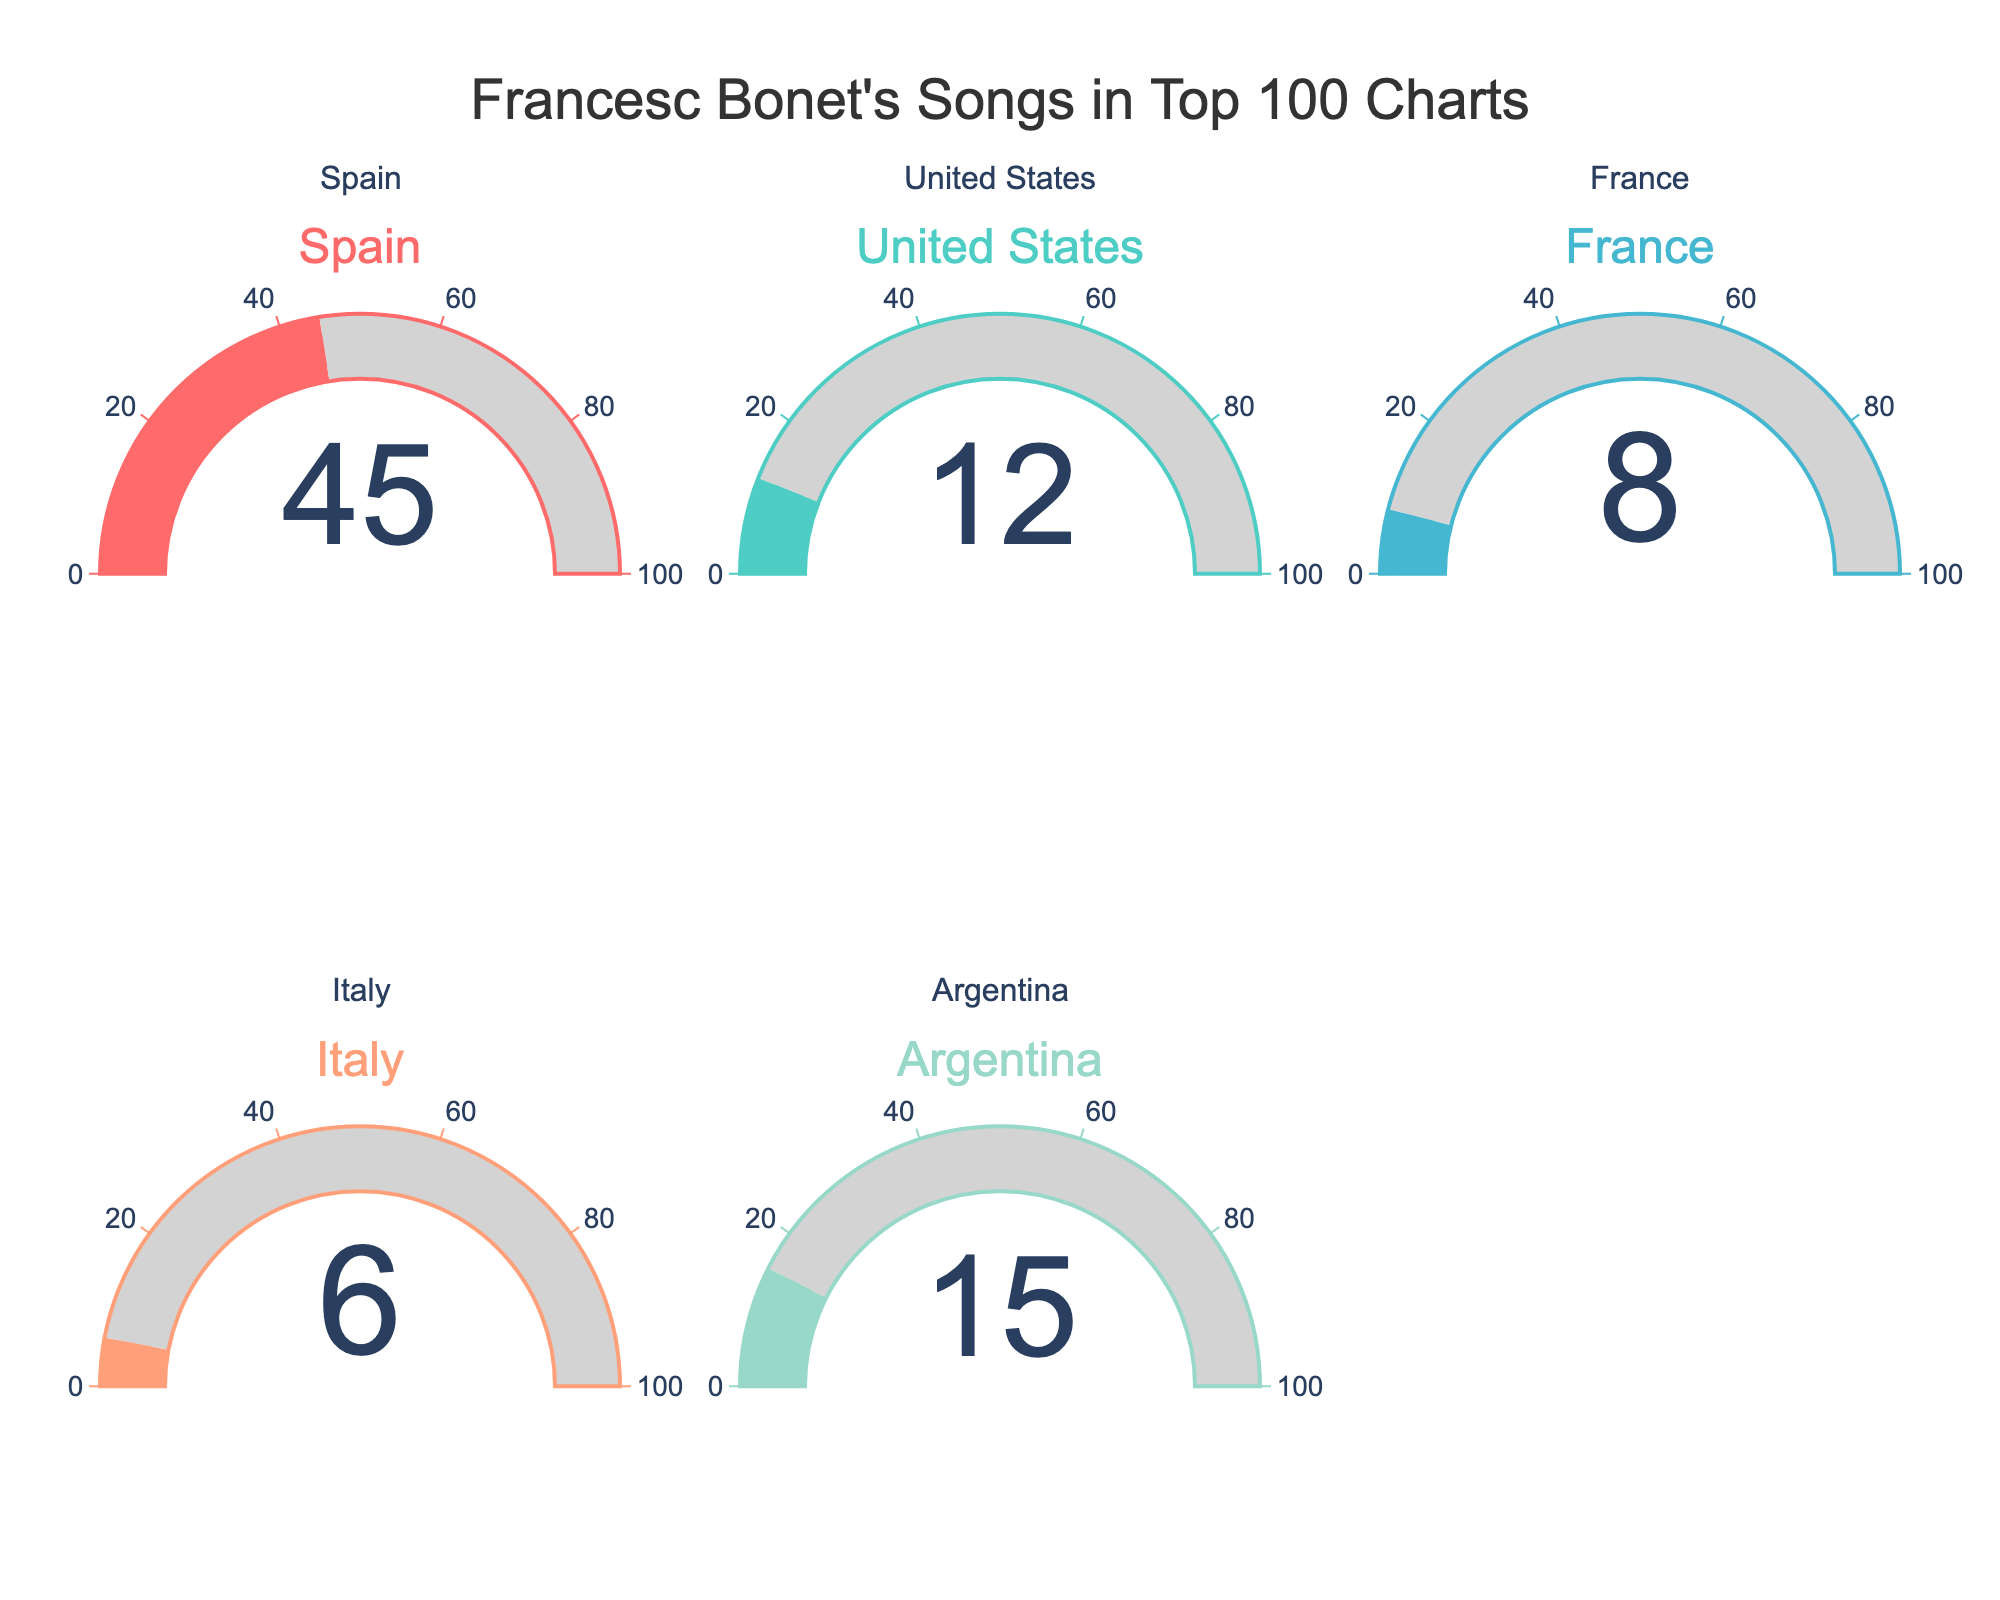which country has the highest percentage of Francesc Bonet's songs in the top 100 charts? The gauge chart shows the percentage values for different countries. The highest percentage is shown for Spain.
Answer: Spain what is the total percentage of Francesc Bonet's songs in the top 100 charts across all displayed countries? Adding up the percentages from the figure: 45 (Spain) + 12 (United States) + 8 (France) + 6 (Italy) + 15 (Argentina) = 86%
Answer: 86% which country has the smallest percentage of Francesc Bonet's songs in the top 100 charts? The gauge chart shows the lowest percentage is for Italy.
Answer: Italy how much higher is the percentage in Spain compared to the United States? The percentage for Spain is 45% and for the United States is 12%. The difference is 45% - 12% = 33%.
Answer: 33% what is the average percentage of Francesc Bonet's songs in the top 100 charts across all displayed countries? Adding the percentages: 45 (Spain) + 12 (United States) + 8 (France) + 6 (Italy) + 15 (Argentina) = 86. There are 5 countries, so the average is 86 / 5 = 17.2%.
Answer: 17.2% which countries have a higher percentage of Francesc Bonet's songs in the top 100 charts than Argentina? Argentina has a percentage of 15%. The countries with higher percentages are Spain (45%).
Answer: Spain which two countries have the closest percentage of Francesc Bonet's songs in the top 100 charts? Comparing the given percentages: Spain (45), United States (12), France (8), Italy (6), Argentina (15). The closest two are France and Italy with a difference of 2% (8% - 6%).
Answer: France and Italy if you combined the percentage of France and Italy's contributions, how would the total percentage compare to that of Spain? France (8%) + Italy (6%) = 14%. Comparing with Spain's 45%, 45% - 14% = 31%, meaning France and Italy together still have a 31% lower contribution.
Answer: Spain is 31% higher 